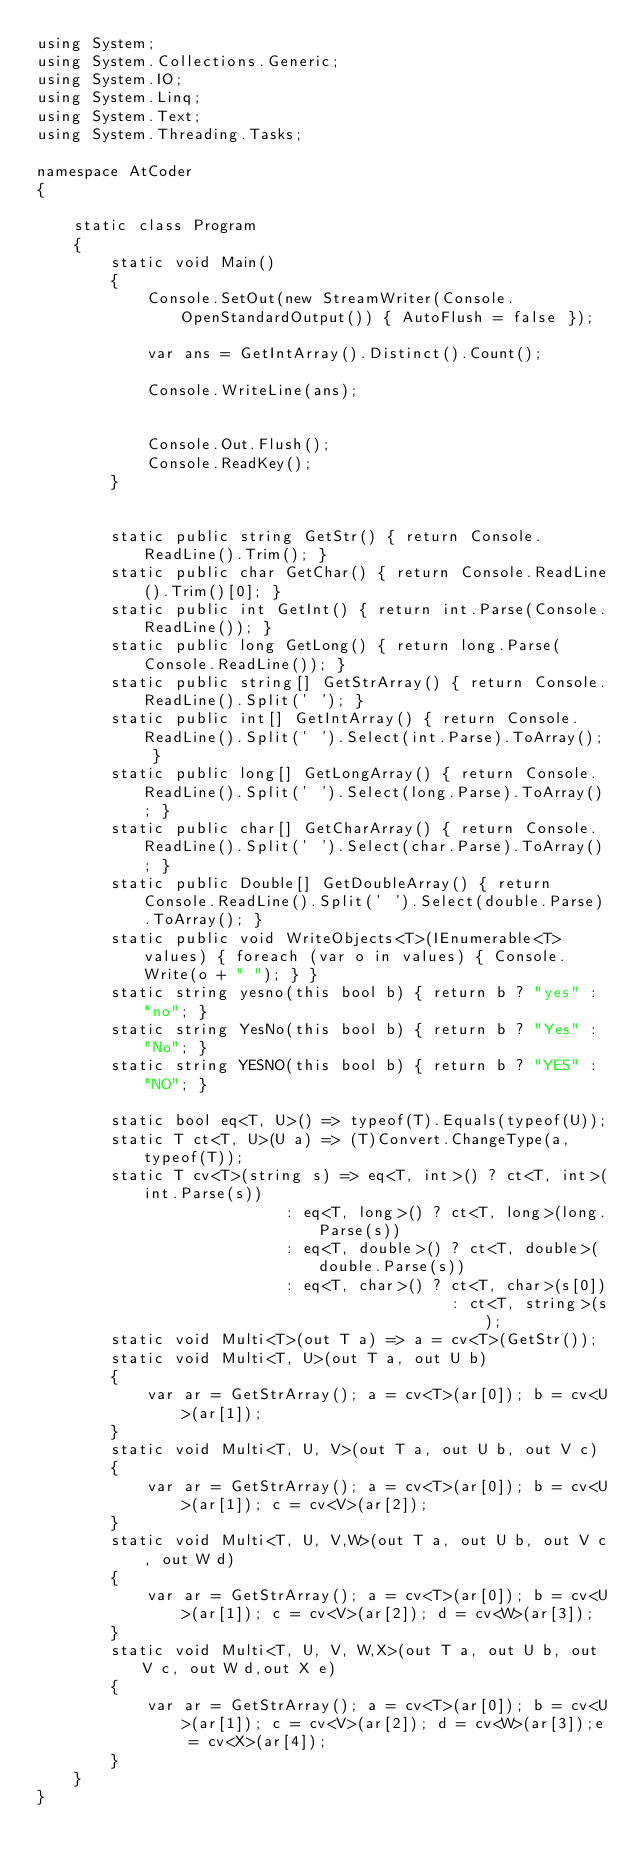<code> <loc_0><loc_0><loc_500><loc_500><_C#_>using System;
using System.Collections.Generic;
using System.IO;
using System.Linq;
using System.Text;
using System.Threading.Tasks;

namespace AtCoder
{

    static class Program
    {
        static void Main()
        {
            Console.SetOut(new StreamWriter(Console.OpenStandardOutput()) { AutoFlush = false });

            var ans = GetIntArray().Distinct().Count();

            Console.WriteLine(ans);


            Console.Out.Flush();
            Console.ReadKey();
        }


        static public string GetStr() { return Console.ReadLine().Trim(); }
        static public char GetChar() { return Console.ReadLine().Trim()[0]; }
        static public int GetInt() { return int.Parse(Console.ReadLine()); }
        static public long GetLong() { return long.Parse(Console.ReadLine()); }
        static public string[] GetStrArray() { return Console.ReadLine().Split(' '); }
        static public int[] GetIntArray() { return Console.ReadLine().Split(' ').Select(int.Parse).ToArray(); }
        static public long[] GetLongArray() { return Console.ReadLine().Split(' ').Select(long.Parse).ToArray(); }
        static public char[] GetCharArray() { return Console.ReadLine().Split(' ').Select(char.Parse).ToArray(); }
        static public Double[] GetDoubleArray() { return Console.ReadLine().Split(' ').Select(double.Parse).ToArray(); }
        static public void WriteObjects<T>(IEnumerable<T> values) { foreach (var o in values) { Console.Write(o + " "); } }
        static string yesno(this bool b) { return b ? "yes" : "no"; }
        static string YesNo(this bool b) { return b ? "Yes" : "No"; }
        static string YESNO(this bool b) { return b ? "YES" : "NO"; }

        static bool eq<T, U>() => typeof(T).Equals(typeof(U));
        static T ct<T, U>(U a) => (T)Convert.ChangeType(a, typeof(T));
        static T cv<T>(string s) => eq<T, int>() ? ct<T, int>(int.Parse(s))
                           : eq<T, long>() ? ct<T, long>(long.Parse(s))
                           : eq<T, double>() ? ct<T, double>(double.Parse(s))
                           : eq<T, char>() ? ct<T, char>(s[0])
                                             : ct<T, string>(s);
        static void Multi<T>(out T a) => a = cv<T>(GetStr());
        static void Multi<T, U>(out T a, out U b)
        {
            var ar = GetStrArray(); a = cv<T>(ar[0]); b = cv<U>(ar[1]);
        }
        static void Multi<T, U, V>(out T a, out U b, out V c)
        {
            var ar = GetStrArray(); a = cv<T>(ar[0]); b = cv<U>(ar[1]); c = cv<V>(ar[2]);
        }
        static void Multi<T, U, V,W>(out T a, out U b, out V c, out W d)
        {
            var ar = GetStrArray(); a = cv<T>(ar[0]); b = cv<U>(ar[1]); c = cv<V>(ar[2]); d = cv<W>(ar[3]);
        }
        static void Multi<T, U, V, W,X>(out T a, out U b, out V c, out W d,out X e)
        {
            var ar = GetStrArray(); a = cv<T>(ar[0]); b = cv<U>(ar[1]); c = cv<V>(ar[2]); d = cv<W>(ar[3]);e = cv<X>(ar[4]);
        }
    }
}</code> 